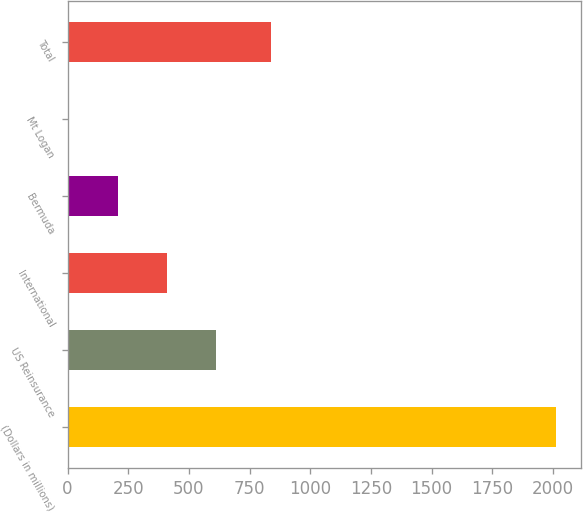<chart> <loc_0><loc_0><loc_500><loc_500><bar_chart><fcel>(Dollars in millions)<fcel>US Reinsurance<fcel>International<fcel>Bermuda<fcel>Mt Logan<fcel>Total<nl><fcel>2014<fcel>610.08<fcel>408.94<fcel>207.8<fcel>2.6<fcel>836.5<nl></chart> 